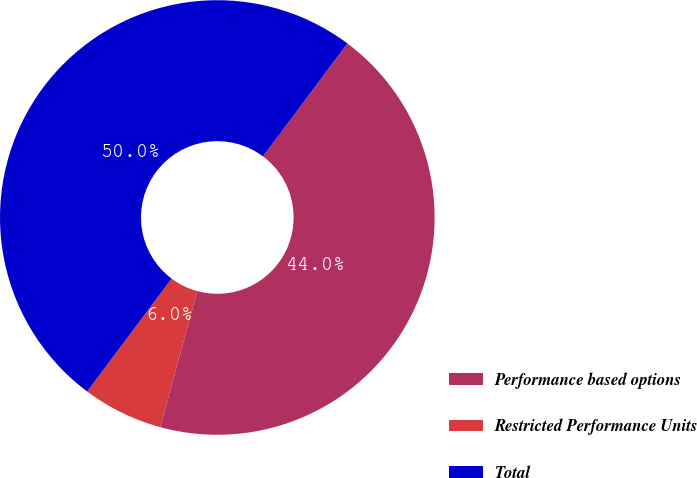<chart> <loc_0><loc_0><loc_500><loc_500><pie_chart><fcel>Performance based options<fcel>Restricted Performance Units<fcel>Total<nl><fcel>44.01%<fcel>5.99%<fcel>50.0%<nl></chart> 